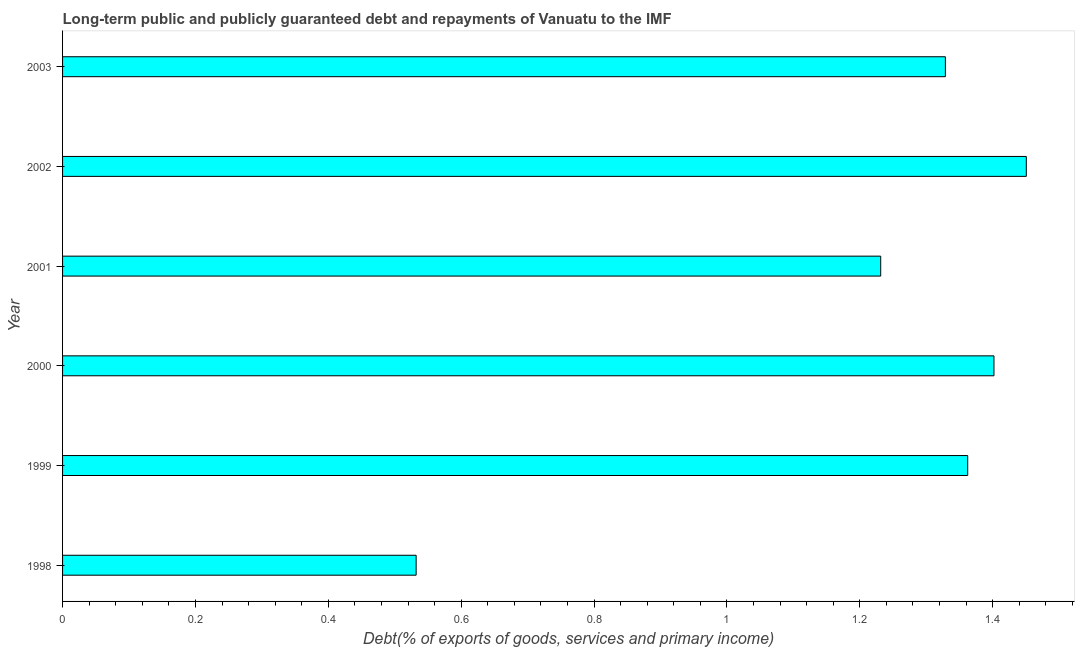Does the graph contain grids?
Make the answer very short. No. What is the title of the graph?
Offer a very short reply. Long-term public and publicly guaranteed debt and repayments of Vanuatu to the IMF. What is the label or title of the X-axis?
Your response must be concise. Debt(% of exports of goods, services and primary income). What is the debt service in 1999?
Provide a short and direct response. 1.36. Across all years, what is the maximum debt service?
Your answer should be compact. 1.45. Across all years, what is the minimum debt service?
Make the answer very short. 0.53. In which year was the debt service maximum?
Your answer should be compact. 2002. In which year was the debt service minimum?
Make the answer very short. 1998. What is the sum of the debt service?
Offer a terse response. 7.31. What is the difference between the debt service in 1999 and 2001?
Make the answer very short. 0.13. What is the average debt service per year?
Provide a short and direct response. 1.22. What is the median debt service?
Your response must be concise. 1.35. In how many years, is the debt service greater than 1.36 %?
Your response must be concise. 3. What is the ratio of the debt service in 1999 to that in 2002?
Ensure brevity in your answer.  0.94. What is the difference between the highest and the second highest debt service?
Your answer should be very brief. 0.05. Is the sum of the debt service in 2000 and 2001 greater than the maximum debt service across all years?
Offer a very short reply. Yes. What is the difference between the highest and the lowest debt service?
Ensure brevity in your answer.  0.92. In how many years, is the debt service greater than the average debt service taken over all years?
Ensure brevity in your answer.  5. How many bars are there?
Your answer should be compact. 6. Are all the bars in the graph horizontal?
Keep it short and to the point. Yes. What is the Debt(% of exports of goods, services and primary income) of 1998?
Keep it short and to the point. 0.53. What is the Debt(% of exports of goods, services and primary income) of 1999?
Make the answer very short. 1.36. What is the Debt(% of exports of goods, services and primary income) in 2000?
Keep it short and to the point. 1.4. What is the Debt(% of exports of goods, services and primary income) of 2001?
Your response must be concise. 1.23. What is the Debt(% of exports of goods, services and primary income) in 2002?
Your answer should be very brief. 1.45. What is the Debt(% of exports of goods, services and primary income) of 2003?
Offer a very short reply. 1.33. What is the difference between the Debt(% of exports of goods, services and primary income) in 1998 and 1999?
Keep it short and to the point. -0.83. What is the difference between the Debt(% of exports of goods, services and primary income) in 1998 and 2000?
Keep it short and to the point. -0.87. What is the difference between the Debt(% of exports of goods, services and primary income) in 1998 and 2001?
Your answer should be compact. -0.7. What is the difference between the Debt(% of exports of goods, services and primary income) in 1998 and 2002?
Provide a short and direct response. -0.92. What is the difference between the Debt(% of exports of goods, services and primary income) in 1998 and 2003?
Ensure brevity in your answer.  -0.8. What is the difference between the Debt(% of exports of goods, services and primary income) in 1999 and 2000?
Make the answer very short. -0.04. What is the difference between the Debt(% of exports of goods, services and primary income) in 1999 and 2001?
Provide a short and direct response. 0.13. What is the difference between the Debt(% of exports of goods, services and primary income) in 1999 and 2002?
Provide a short and direct response. -0.09. What is the difference between the Debt(% of exports of goods, services and primary income) in 1999 and 2003?
Ensure brevity in your answer.  0.03. What is the difference between the Debt(% of exports of goods, services and primary income) in 2000 and 2001?
Your answer should be compact. 0.17. What is the difference between the Debt(% of exports of goods, services and primary income) in 2000 and 2002?
Your response must be concise. -0.05. What is the difference between the Debt(% of exports of goods, services and primary income) in 2000 and 2003?
Offer a very short reply. 0.07. What is the difference between the Debt(% of exports of goods, services and primary income) in 2001 and 2002?
Provide a succinct answer. -0.22. What is the difference between the Debt(% of exports of goods, services and primary income) in 2001 and 2003?
Provide a short and direct response. -0.1. What is the difference between the Debt(% of exports of goods, services and primary income) in 2002 and 2003?
Keep it short and to the point. 0.12. What is the ratio of the Debt(% of exports of goods, services and primary income) in 1998 to that in 1999?
Give a very brief answer. 0.39. What is the ratio of the Debt(% of exports of goods, services and primary income) in 1998 to that in 2000?
Your answer should be compact. 0.38. What is the ratio of the Debt(% of exports of goods, services and primary income) in 1998 to that in 2001?
Provide a short and direct response. 0.43. What is the ratio of the Debt(% of exports of goods, services and primary income) in 1998 to that in 2002?
Offer a very short reply. 0.37. What is the ratio of the Debt(% of exports of goods, services and primary income) in 1998 to that in 2003?
Your response must be concise. 0.4. What is the ratio of the Debt(% of exports of goods, services and primary income) in 1999 to that in 2000?
Your answer should be very brief. 0.97. What is the ratio of the Debt(% of exports of goods, services and primary income) in 1999 to that in 2001?
Give a very brief answer. 1.11. What is the ratio of the Debt(% of exports of goods, services and primary income) in 1999 to that in 2002?
Your answer should be very brief. 0.94. What is the ratio of the Debt(% of exports of goods, services and primary income) in 2000 to that in 2001?
Offer a very short reply. 1.14. What is the ratio of the Debt(% of exports of goods, services and primary income) in 2000 to that in 2003?
Offer a terse response. 1.05. What is the ratio of the Debt(% of exports of goods, services and primary income) in 2001 to that in 2002?
Offer a very short reply. 0.85. What is the ratio of the Debt(% of exports of goods, services and primary income) in 2001 to that in 2003?
Provide a short and direct response. 0.93. What is the ratio of the Debt(% of exports of goods, services and primary income) in 2002 to that in 2003?
Your answer should be very brief. 1.09. 